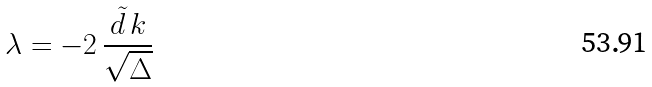<formula> <loc_0><loc_0><loc_500><loc_500>\lambda = - 2 \, \frac { { \tilde { d } } \, k } { \sqrt { \Delta } }</formula> 